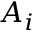Convert formula to latex. <formula><loc_0><loc_0><loc_500><loc_500>A _ { i }</formula> 